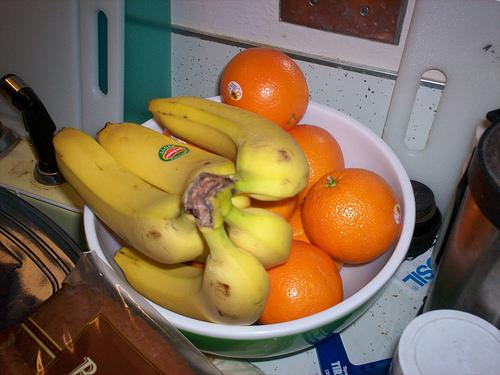Question: how many bowls are there?
Choices:
A. Two.
B. One.
C. Three.
D. Four.
Answer with the letter. Answer: B Question: why is it so bright?
Choices:
A. The sun is shining.
B. The lights are shining.
C. The light is on.
D. Headlights are shining.
Answer with the letter. Answer: C Question: what is under the bananas?
Choices:
A. Grapes.
B. Eggplant.
C. Pears.
D. Oranges.
Answer with the letter. Answer: D Question: what is on the oranges?
Choices:
A. Grapes.
B. Grapefruit.
C. Strawberries.
D. Bananas.
Answer with the letter. Answer: D Question: how many bananas are there?
Choices:
A. One.
B. Two.
C. Three.
D. Five.
Answer with the letter. Answer: D Question: what is in the bowl?
Choices:
A. Fruit.
B. Sausage.
C. Cereal.
D. Soup.
Answer with the letter. Answer: A 